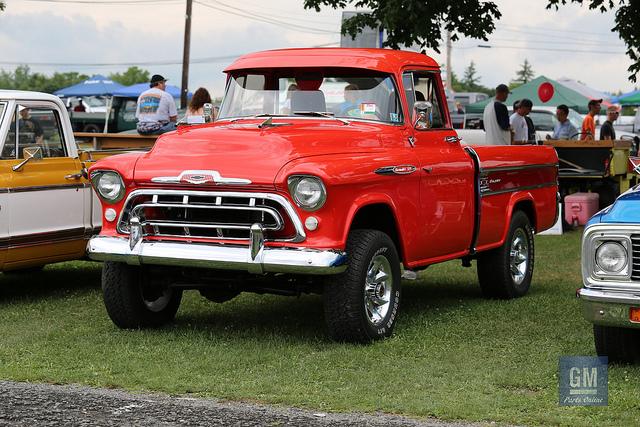How many tents are there?
Give a very brief answer. 4. How many tires can be seen in this picture?
Keep it brief. 4. Is the red truck contemporary or classic?
Keep it brief. Classic. Who is driving the truck?
Be succinct. Nobody. What are the sides of the car made out of?
Answer briefly. Metal. What type of vehicles are these?
Short answer required. Trucks. Are only trucks parked in the lot shown?
Answer briefly. Yes. Where is the red car?
Be succinct. On grass. What color is the truck?
Be succinct. Red. Does this vehicle look street legal?
Write a very short answer. Yes. Is the hood popped?
Quick response, please. No. 